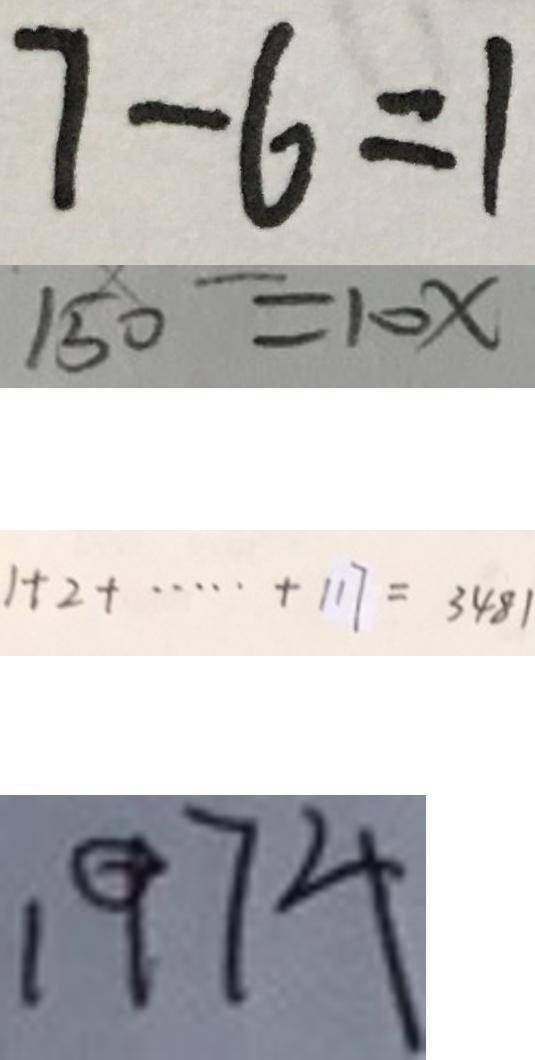Convert formula to latex. <formula><loc_0><loc_0><loc_500><loc_500>7 - 6 = 1 
 1 5 0 = 1 0 x 
 1 + 2 + \cdots + 1 1 7 = 3 4 8 1 
 1 9 7 4</formula> 